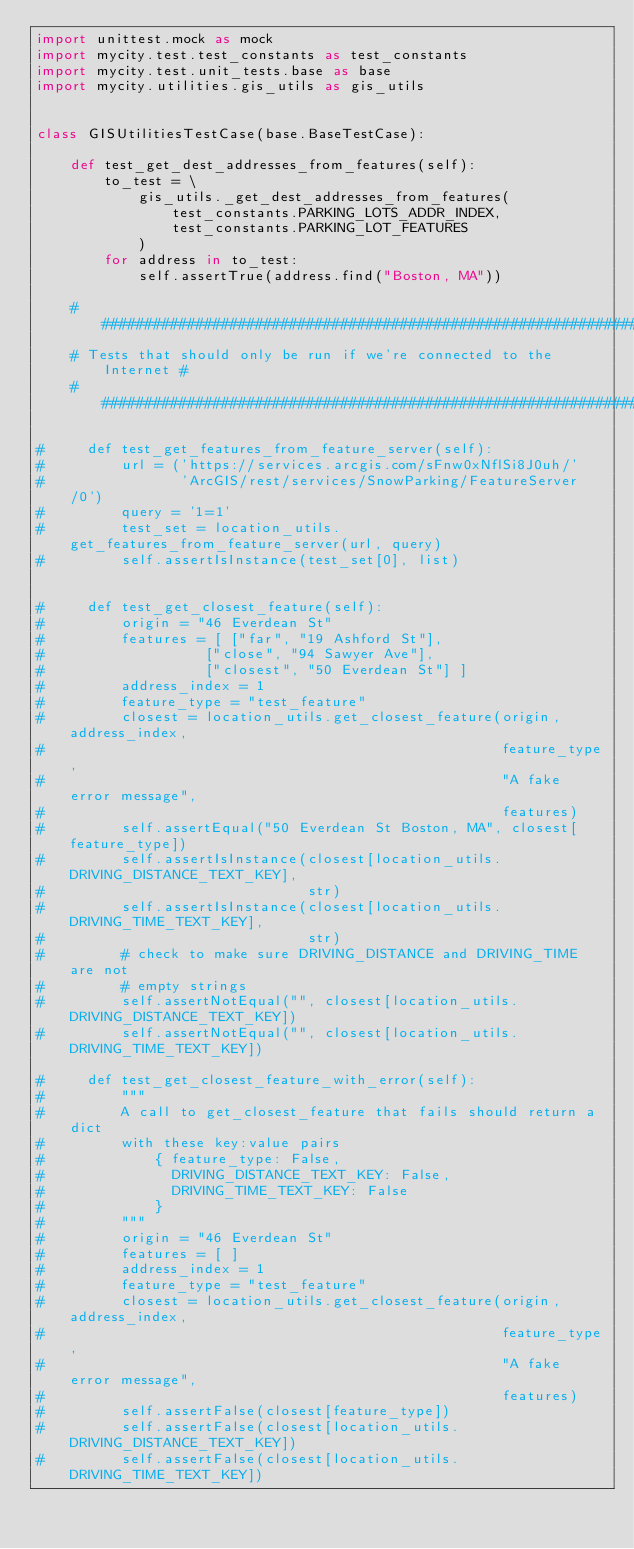Convert code to text. <code><loc_0><loc_0><loc_500><loc_500><_Python_>import unittest.mock as mock
import mycity.test.test_constants as test_constants
import mycity.test.unit_tests.base as base
import mycity.utilities.gis_utils as gis_utils


class GISUtilitiesTestCase(base.BaseTestCase):

    def test_get_dest_addresses_from_features(self):
        to_test = \
            gis_utils._get_dest_addresses_from_features(
                test_constants.PARKING_LOTS_ADDR_INDEX,
                test_constants.PARKING_LOT_FEATURES
            )
        for address in to_test:
            self.assertTrue(address.find("Boston, MA"))

    ####################################################################
    # Tests that should only be run if we're connected to the Internet #
    ####################################################################

#     def test_get_features_from_feature_server(self):
#         url = ('https://services.arcgis.com/sFnw0xNflSi8J0uh/'
#                'ArcGIS/rest/services/SnowParking/FeatureServer/0')
#         query = '1=1'
#         test_set = location_utils.get_features_from_feature_server(url, query)
#         self.assertIsInstance(test_set[0], list)


#     def test_get_closest_feature(self):
#         origin = "46 Everdean St"
#         features = [ ["far", "19 Ashford St"],
#                   ["close", "94 Sawyer Ave"],
#                   ["closest", "50 Everdean St"] ]
#         address_index = 1
#         feature_type = "test_feature"
#         closest = location_utils.get_closest_feature(origin, address_index, 
#                                                      feature_type,
#                                                      "A fake error message",
#                                                      features)
#         self.assertEqual("50 Everdean St Boston, MA", closest[feature_type])
#         self.assertIsInstance(closest[location_utils.DRIVING_DISTANCE_TEXT_KEY],
#                               str)
#         self.assertIsInstance(closest[location_utils.DRIVING_TIME_TEXT_KEY],
#                               str)
#         # check to make sure DRIVING_DISTANCE and DRIVING_TIME are not 
#         # empty strings
#         self.assertNotEqual("", closest[location_utils.DRIVING_DISTANCE_TEXT_KEY])
#         self.assertNotEqual("", closest[location_utils.DRIVING_TIME_TEXT_KEY])

#     def test_get_closest_feature_with_error(self):
#         """
#         A call to get_closest_feature that fails should return a dict
#         with these key:value pairs
#             { feature_type: False,
#               DRIVING_DISTANCE_TEXT_KEY: False,
#               DRIVING_TIME_TEXT_KEY: False 
#             }
#         """
#         origin = "46 Everdean St"
#         features = [ ]
#         address_index = 1
#         feature_type = "test_feature"
#         closest = location_utils.get_closest_feature(origin, address_index,
#                                                      feature_type,
#                                                      "A fake error message",
#                                                      features)
#         self.assertFalse(closest[feature_type])
#         self.assertFalse(closest[location_utils.DRIVING_DISTANCE_TEXT_KEY])
#         self.assertFalse(closest[location_utils.DRIVING_TIME_TEXT_KEY])

</code> 